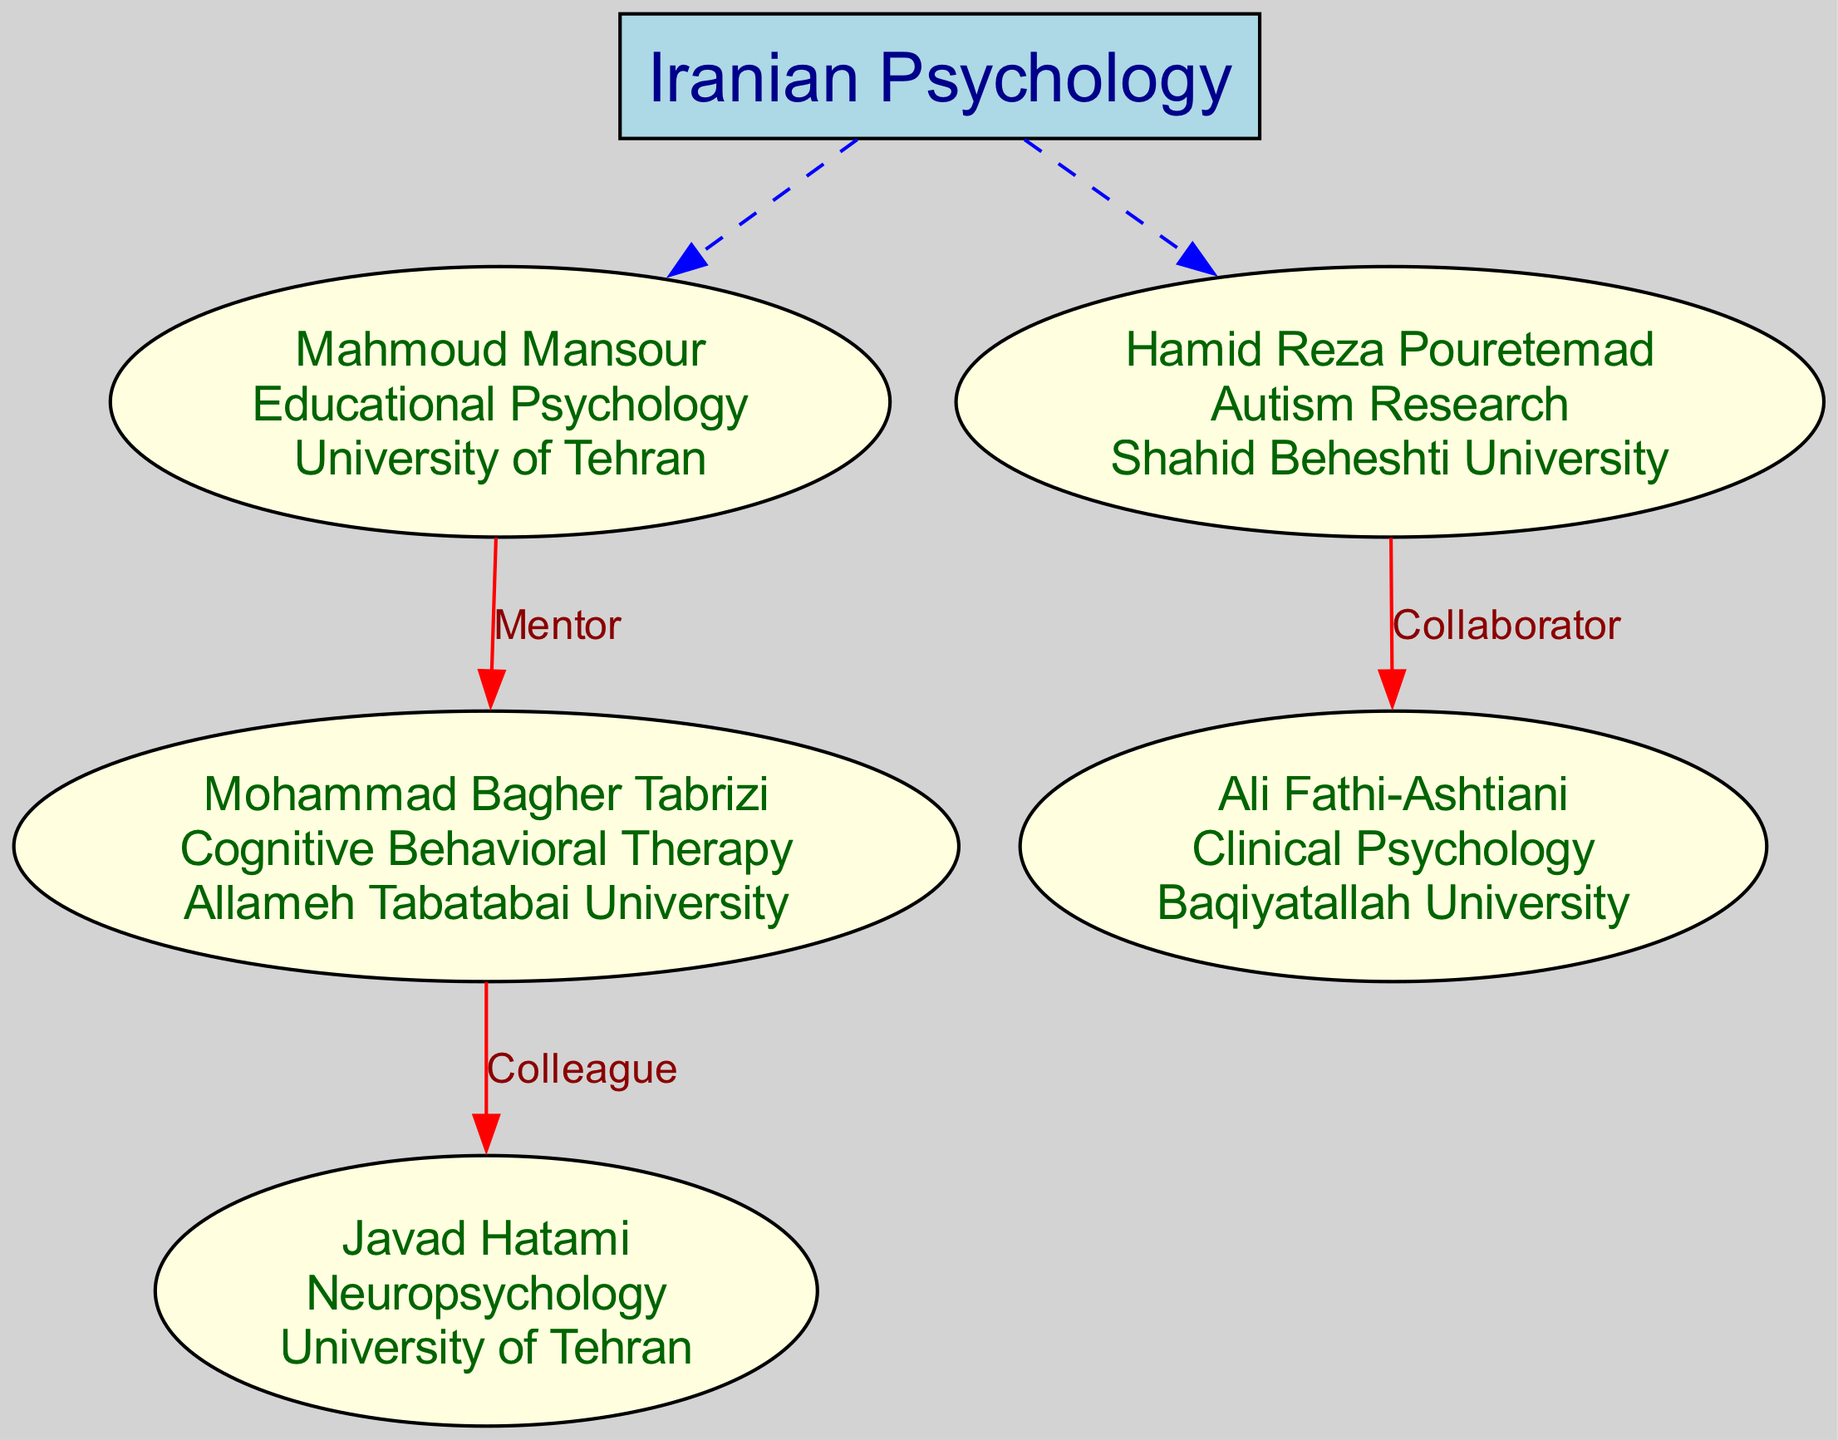What is the primary contribution of Mohammad Bagher Tabrizi? The diagram indicates that Mohammad Bagher Tabrizi's primary contribution is "Cognitive Behavioral Therapy". This information is included in his node in the diagram.
Answer: Cognitive Behavioral Therapy How many psychologists are represented in the family tree? The diagram lists five nodes under the root "Iranian Psychology", each representing a psychologist. Counting these nodes provides the total number represented in the tree.
Answer: 5 What is the relationship between Mahmoud Mansour and Mohammad Bagher Tabrizi? The diagram shows a directed edge from Mahmoud Mansour to Mohammad Bagher Tabrizi labeled as "Mentor", indicating that Mahmoud Mansour is the mentor of Mohammad Bagher Tabrizi.
Answer: Mentor Which university is associated with Hamid Reza Pouretemad? According to the diagram, Hamid Reza Pouretemad is associated with "Shahid Beheshti University", which is listed on his node.
Answer: Shahid Beheshti University Who collaborated with Ali Fathi-Ashtiani? The diagram shows an edge from Hamid Reza Pouretemad to Ali Fathi-Ashtiani labeled "Collaborator", indicating that Hamid Reza Pouretemad collaborated with Ali Fathi-Ashtiani.
Answer: Hamid Reza Pouretemad What type of psychology does Javad Hatami specialize in? The diagram indicates that Javad Hatami specializes in "Neuropsychology", which is explicitly stated in his node.
Answer: Neuropsychology How many relationships are shown in the diagram? Counting both the "Mentor" and "Collaborator" labels in the edges confirms there are three connections represented in the diagram.
Answer: 3 Which psychologist is a colleague of Mohammad Bagher Tabrizi? The diagram indicates that Javad Hatami is a colleague of Mohammad Bagher Tabrizi, as shown by the connection labeled "Colleague".
Answer: Javad Hatami What type of research does Hamid Reza Pouretemad focus on? The diagram clearly states that Hamid Reza Pouretemad's focus is on "Autism Research", as indicated in his node.
Answer: Autism Research 